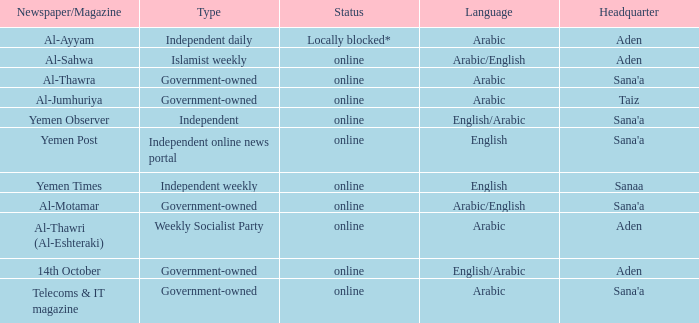What is Headquarter, when Type is Independent Online News Portal? Sana'a. 